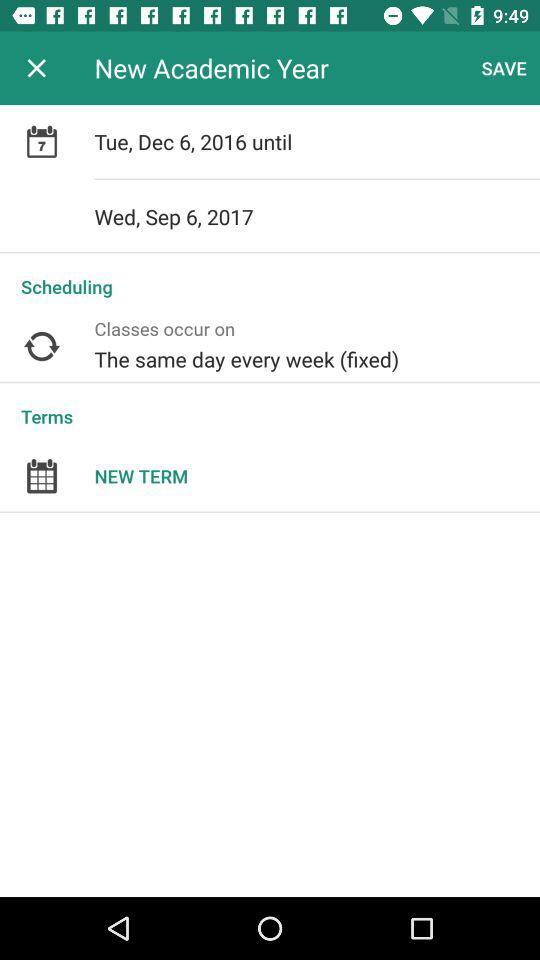What is the date range of the new academic year? The date range of the new academic year is Tuesday, December 6, 2016 until Wednesday, September 6, 2017. 